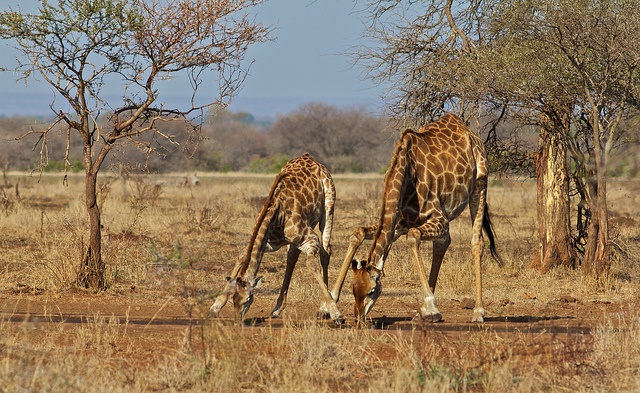Describe the objects in this image and their specific colors. I can see giraffe in darkgray, black, maroon, and brown tones and giraffe in darkgray, black, maroon, tan, and brown tones in this image. 